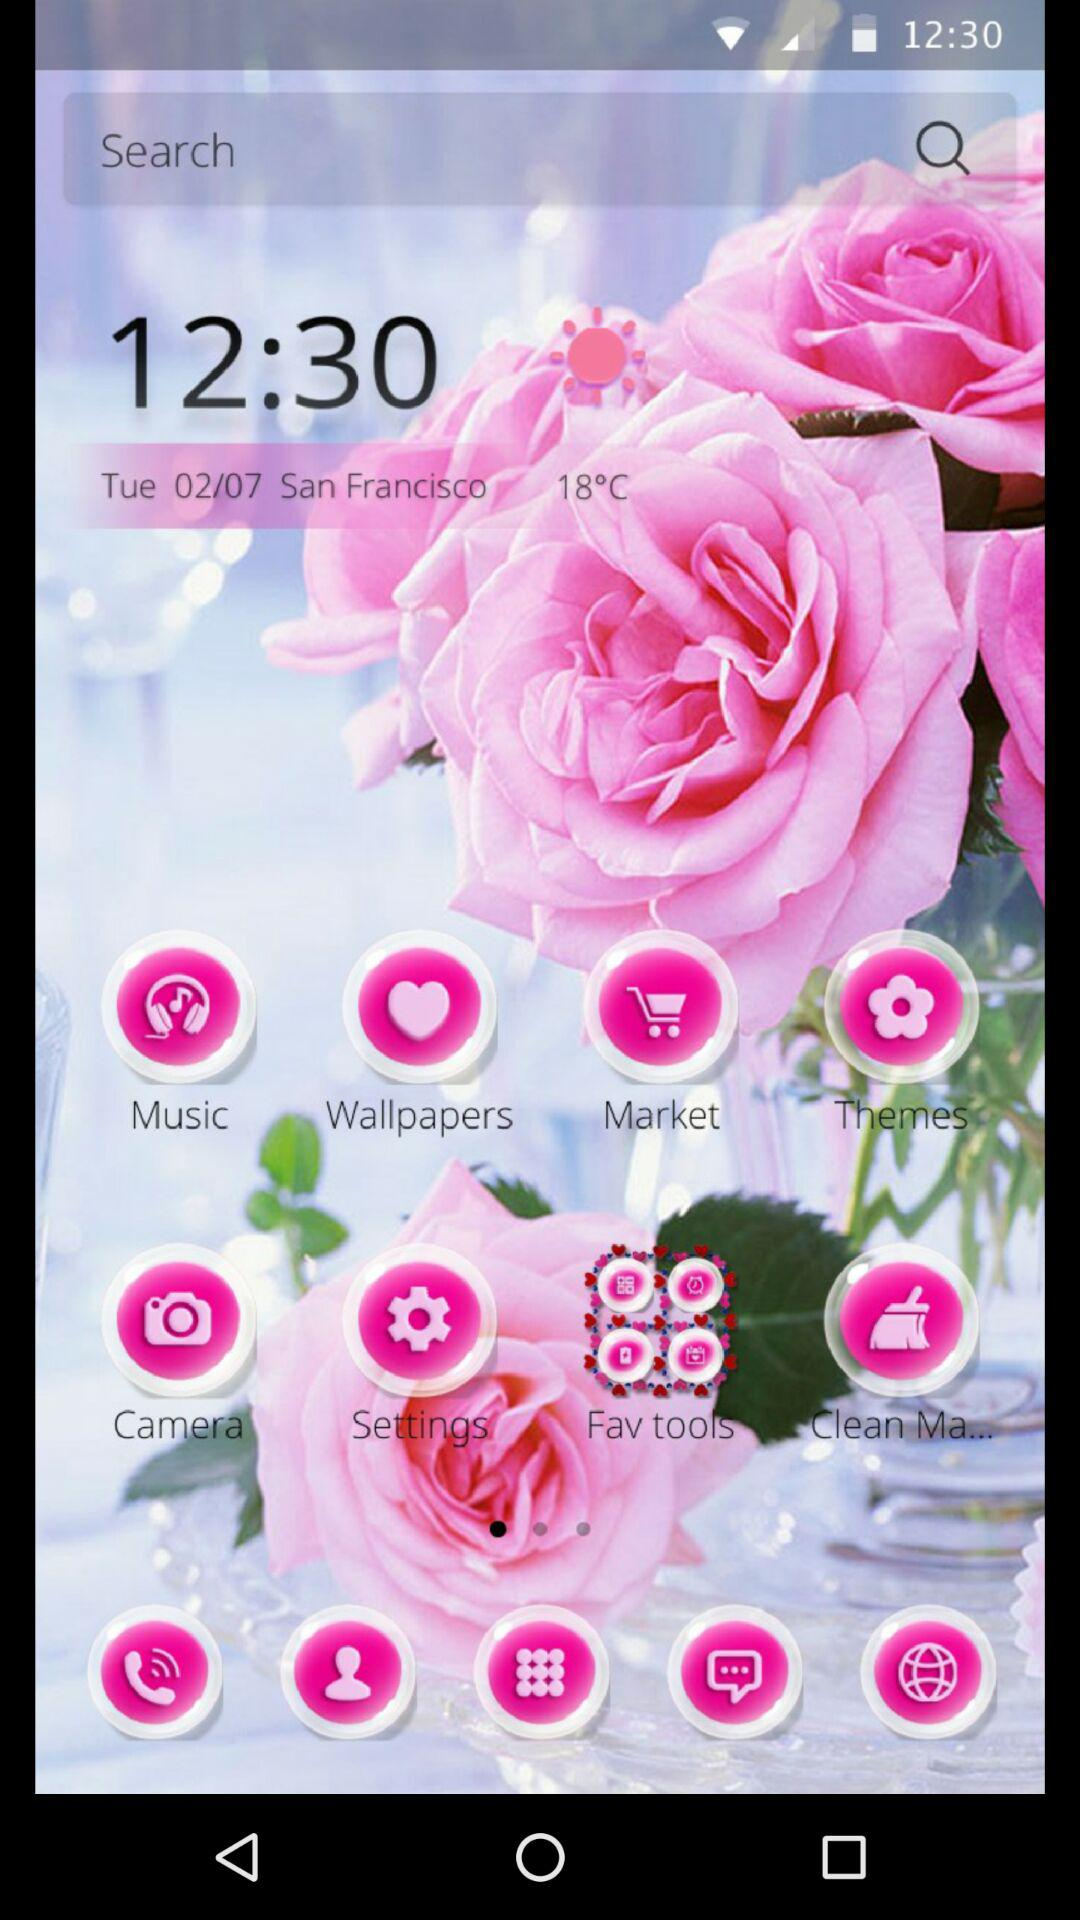What is the temperature? The temperature is 18 °C. 